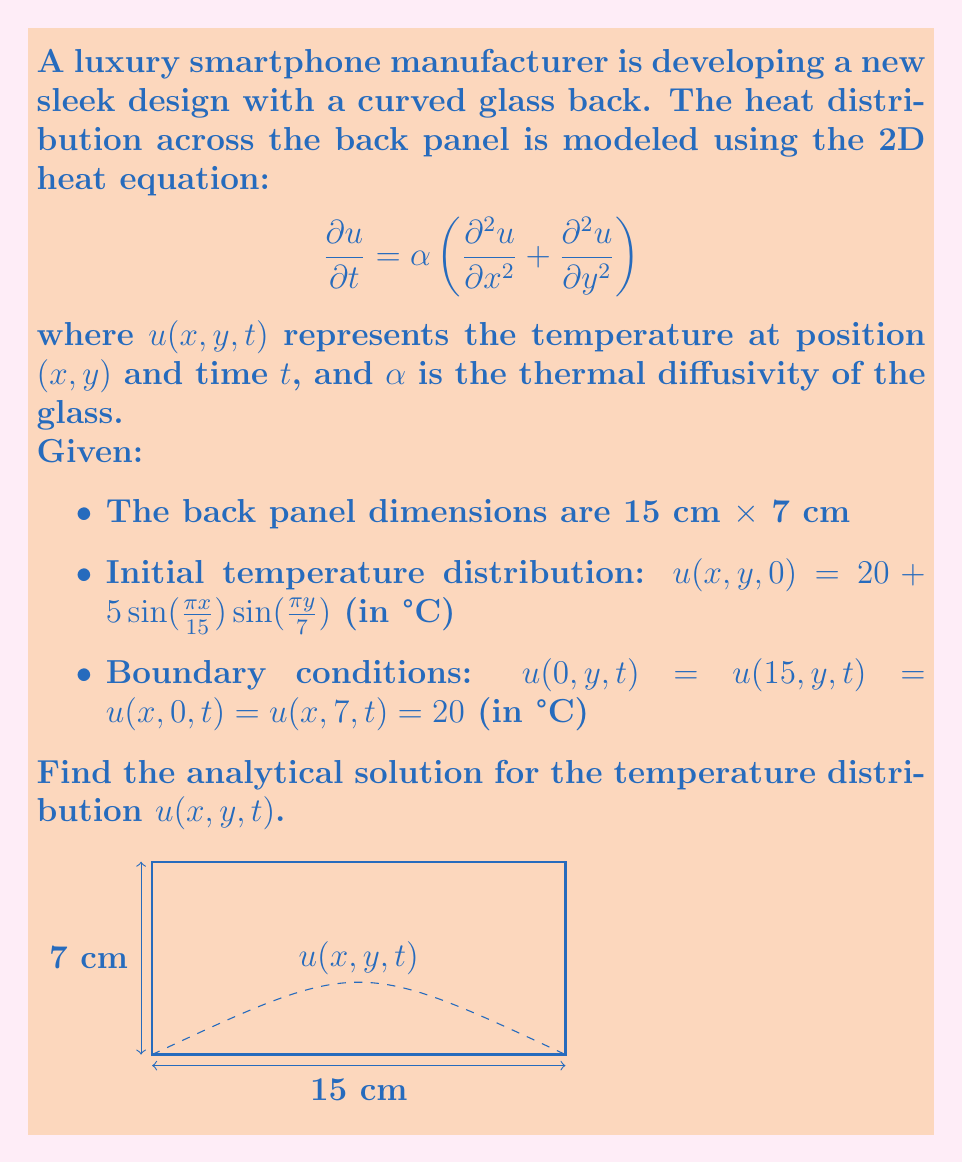Solve this math problem. To solve this partial differential equation (PDE), we'll use the method of separation of variables.

Step 1: Assume the solution has the form $u(x,y,t) = X(x)Y(y)T(t)$.

Step 2: Substitute this into the PDE and separate variables:

$$\frac{T'(t)}{T(t)} = \alpha \left(\frac{X''(x)}{X(x)} + \frac{Y''(y)}{Y(y)}\right) = -\lambda$$

where $\lambda$ is a separation constant.

Step 3: Solve the resulting ODEs:
- $T'(t) + \alpha\lambda T(t) = 0$
- $X''(x) + \mu X(x) = 0$
- $Y''(y) + (\lambda - \mu)Y(y) = 0$

Step 4: Apply boundary conditions:
$X(0) = X(15) = 0$ and $Y(0) = Y(7) = 0$

This gives us:
$X_n(x) = \sin(\frac{n\pi x}{15})$ and $Y_m(y) = \sin(\frac{m\pi y}{7})$

where $n, m = 1, 2, 3, ...$

Step 5: The general solution is:

$$u(x,y,t) = \sum_{n=1}^{\infty}\sum_{m=1}^{\infty} A_{nm} \sin(\frac{n\pi x}{15})\sin(\frac{m\pi y}{7})e^{-\alpha(\frac{n^2\pi^2}{225}+\frac{m^2\pi^2}{49})t}$$

Step 6: Apply the initial condition to find $A_{nm}$:

$$20 + 5\sin(\frac{\pi x}{15})\sin(\frac{\pi y}{7}) = \sum_{n=1}^{\infty}\sum_{m=1}^{\infty} A_{nm} \sin(\frac{n\pi x}{15})\sin(\frac{m\pi y}{7})$$

Comparing coefficients, we get:
$A_{11} = 5$ and $A_{nm} = 0$ for all other $n, m$.

Step 7: The final solution is:

$$u(x,y,t) = 20 + 5\sin(\frac{\pi x}{15})\sin(\frac{\pi y}{7})e^{-\alpha(\frac{\pi^2}{225}+\frac{\pi^2}{49})t}$$
Answer: $u(x,y,t) = 20 + 5\sin(\frac{\pi x}{15})\sin(\frac{\pi y}{7})e^{-\alpha(\frac{\pi^2}{225}+\frac{\pi^2}{49})t}$ 